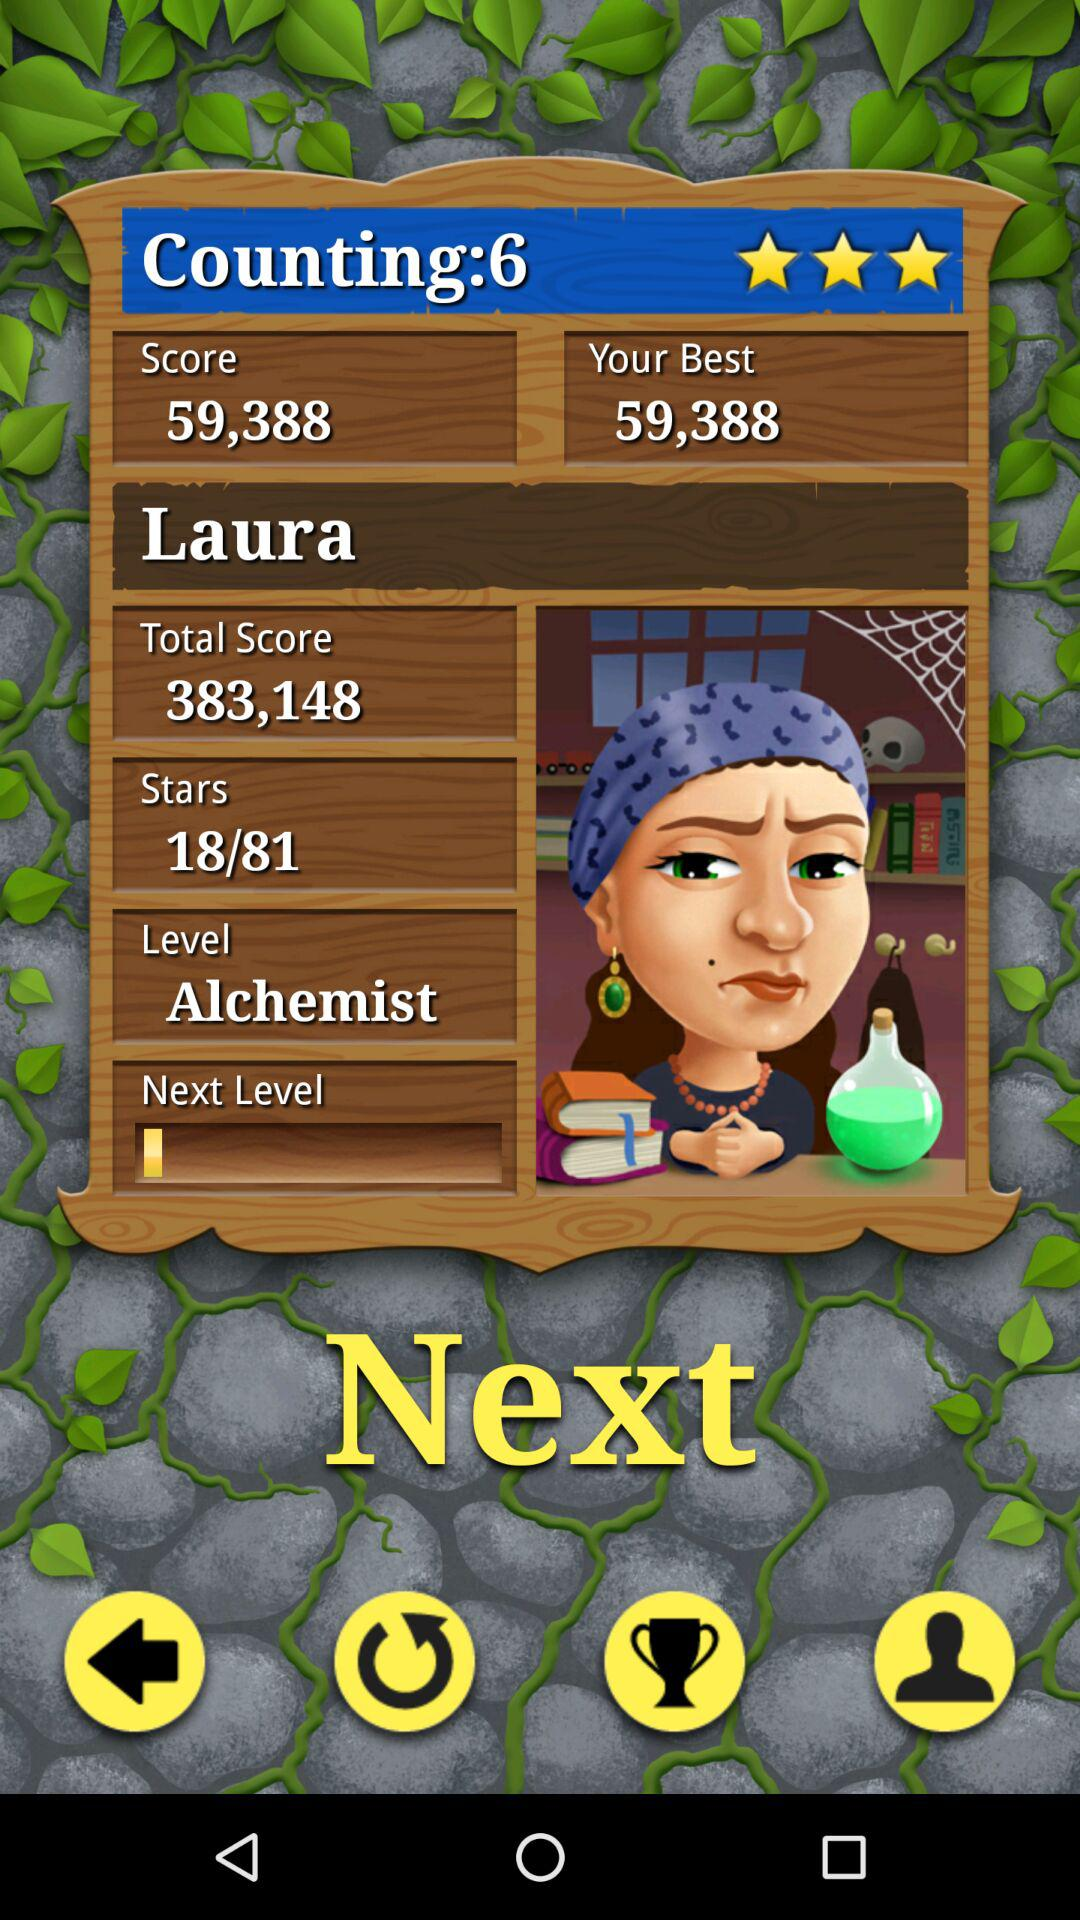What is the score? The score is 59,338. 